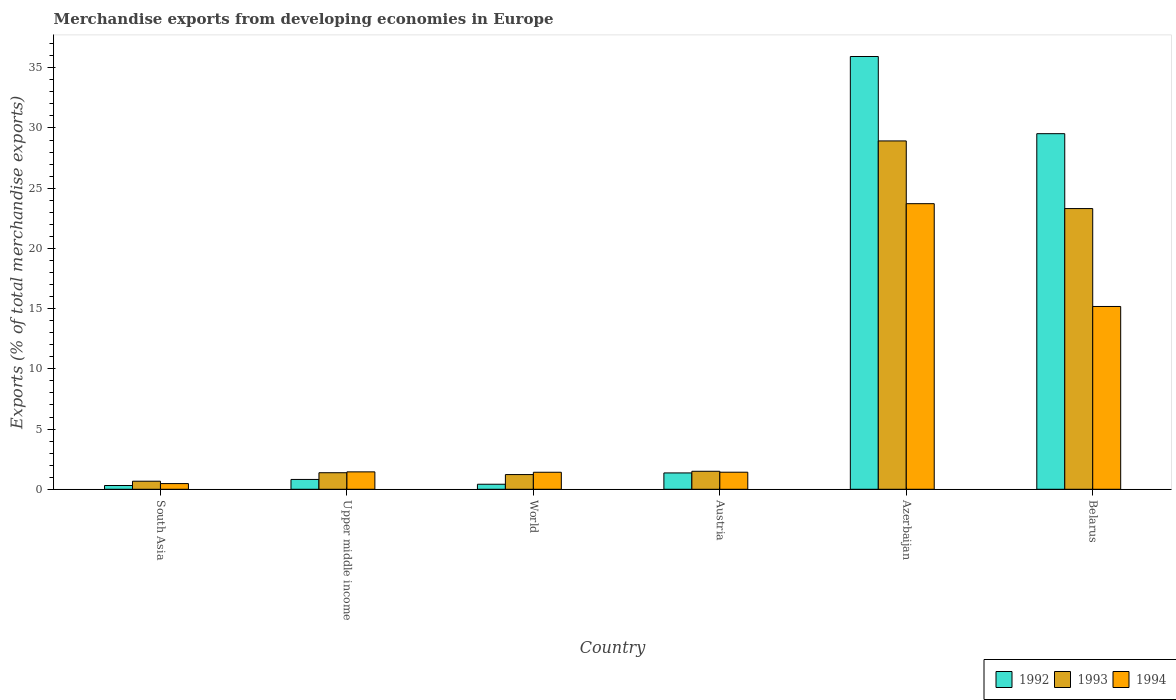How many groups of bars are there?
Ensure brevity in your answer.  6. Are the number of bars per tick equal to the number of legend labels?
Make the answer very short. Yes. How many bars are there on the 5th tick from the left?
Provide a succinct answer. 3. How many bars are there on the 2nd tick from the right?
Offer a very short reply. 3. What is the label of the 6th group of bars from the left?
Offer a terse response. Belarus. In how many cases, is the number of bars for a given country not equal to the number of legend labels?
Offer a terse response. 0. What is the percentage of total merchandise exports in 1992 in South Asia?
Provide a short and direct response. 0.31. Across all countries, what is the maximum percentage of total merchandise exports in 1994?
Provide a short and direct response. 23.72. Across all countries, what is the minimum percentage of total merchandise exports in 1994?
Provide a succinct answer. 0.47. In which country was the percentage of total merchandise exports in 1993 maximum?
Keep it short and to the point. Azerbaijan. What is the total percentage of total merchandise exports in 1992 in the graph?
Your response must be concise. 68.37. What is the difference between the percentage of total merchandise exports in 1992 in Belarus and that in World?
Make the answer very short. 29.11. What is the difference between the percentage of total merchandise exports in 1992 in Azerbaijan and the percentage of total merchandise exports in 1994 in South Asia?
Keep it short and to the point. 35.46. What is the average percentage of total merchandise exports in 1994 per country?
Give a very brief answer. 7.27. What is the difference between the percentage of total merchandise exports of/in 1994 and percentage of total merchandise exports of/in 1992 in Azerbaijan?
Offer a terse response. -12.22. In how many countries, is the percentage of total merchandise exports in 1994 greater than 14 %?
Offer a terse response. 2. What is the ratio of the percentage of total merchandise exports in 1994 in Austria to that in Azerbaijan?
Your answer should be very brief. 0.06. Is the percentage of total merchandise exports in 1993 in Austria less than that in World?
Ensure brevity in your answer.  No. What is the difference between the highest and the second highest percentage of total merchandise exports in 1994?
Your answer should be very brief. -13.73. What is the difference between the highest and the lowest percentage of total merchandise exports in 1993?
Offer a terse response. 28.26. In how many countries, is the percentage of total merchandise exports in 1992 greater than the average percentage of total merchandise exports in 1992 taken over all countries?
Your answer should be compact. 2. What does the 1st bar from the left in South Asia represents?
Ensure brevity in your answer.  1992. What does the 1st bar from the right in South Asia represents?
Provide a short and direct response. 1994. Is it the case that in every country, the sum of the percentage of total merchandise exports in 1992 and percentage of total merchandise exports in 1994 is greater than the percentage of total merchandise exports in 1993?
Provide a short and direct response. Yes. Are the values on the major ticks of Y-axis written in scientific E-notation?
Offer a terse response. No. Does the graph contain any zero values?
Offer a terse response. No. Does the graph contain grids?
Offer a very short reply. No. How many legend labels are there?
Make the answer very short. 3. What is the title of the graph?
Your response must be concise. Merchandise exports from developing economies in Europe. Does "1993" appear as one of the legend labels in the graph?
Your answer should be very brief. Yes. What is the label or title of the Y-axis?
Offer a very short reply. Exports (% of total merchandise exports). What is the Exports (% of total merchandise exports) in 1992 in South Asia?
Ensure brevity in your answer.  0.31. What is the Exports (% of total merchandise exports) in 1993 in South Asia?
Provide a short and direct response. 0.67. What is the Exports (% of total merchandise exports) in 1994 in South Asia?
Ensure brevity in your answer.  0.47. What is the Exports (% of total merchandise exports) in 1992 in Upper middle income?
Provide a succinct answer. 0.82. What is the Exports (% of total merchandise exports) in 1993 in Upper middle income?
Offer a very short reply. 1.37. What is the Exports (% of total merchandise exports) of 1994 in Upper middle income?
Make the answer very short. 1.45. What is the Exports (% of total merchandise exports) of 1992 in World?
Your answer should be very brief. 0.42. What is the Exports (% of total merchandise exports) of 1993 in World?
Give a very brief answer. 1.22. What is the Exports (% of total merchandise exports) of 1994 in World?
Make the answer very short. 1.41. What is the Exports (% of total merchandise exports) in 1992 in Austria?
Your answer should be very brief. 1.36. What is the Exports (% of total merchandise exports) of 1993 in Austria?
Give a very brief answer. 1.49. What is the Exports (% of total merchandise exports) of 1994 in Austria?
Your response must be concise. 1.42. What is the Exports (% of total merchandise exports) in 1992 in Azerbaijan?
Ensure brevity in your answer.  35.94. What is the Exports (% of total merchandise exports) in 1993 in Azerbaijan?
Ensure brevity in your answer.  28.93. What is the Exports (% of total merchandise exports) of 1994 in Azerbaijan?
Give a very brief answer. 23.72. What is the Exports (% of total merchandise exports) of 1992 in Belarus?
Make the answer very short. 29.53. What is the Exports (% of total merchandise exports) of 1993 in Belarus?
Give a very brief answer. 23.31. What is the Exports (% of total merchandise exports) in 1994 in Belarus?
Make the answer very short. 15.18. Across all countries, what is the maximum Exports (% of total merchandise exports) of 1992?
Provide a short and direct response. 35.94. Across all countries, what is the maximum Exports (% of total merchandise exports) of 1993?
Offer a very short reply. 28.93. Across all countries, what is the maximum Exports (% of total merchandise exports) of 1994?
Keep it short and to the point. 23.72. Across all countries, what is the minimum Exports (% of total merchandise exports) of 1992?
Provide a succinct answer. 0.31. Across all countries, what is the minimum Exports (% of total merchandise exports) in 1993?
Make the answer very short. 0.67. Across all countries, what is the minimum Exports (% of total merchandise exports) in 1994?
Give a very brief answer. 0.47. What is the total Exports (% of total merchandise exports) of 1992 in the graph?
Ensure brevity in your answer.  68.37. What is the total Exports (% of total merchandise exports) in 1993 in the graph?
Your answer should be very brief. 57. What is the total Exports (% of total merchandise exports) in 1994 in the graph?
Offer a very short reply. 43.64. What is the difference between the Exports (% of total merchandise exports) of 1992 in South Asia and that in Upper middle income?
Your response must be concise. -0.5. What is the difference between the Exports (% of total merchandise exports) in 1993 in South Asia and that in Upper middle income?
Your answer should be very brief. -0.7. What is the difference between the Exports (% of total merchandise exports) in 1994 in South Asia and that in Upper middle income?
Offer a very short reply. -0.97. What is the difference between the Exports (% of total merchandise exports) of 1992 in South Asia and that in World?
Ensure brevity in your answer.  -0.11. What is the difference between the Exports (% of total merchandise exports) in 1993 in South Asia and that in World?
Your response must be concise. -0.55. What is the difference between the Exports (% of total merchandise exports) in 1994 in South Asia and that in World?
Offer a terse response. -0.94. What is the difference between the Exports (% of total merchandise exports) of 1992 in South Asia and that in Austria?
Offer a terse response. -1.04. What is the difference between the Exports (% of total merchandise exports) of 1993 in South Asia and that in Austria?
Make the answer very short. -0.82. What is the difference between the Exports (% of total merchandise exports) of 1994 in South Asia and that in Austria?
Provide a succinct answer. -0.94. What is the difference between the Exports (% of total merchandise exports) of 1992 in South Asia and that in Azerbaijan?
Ensure brevity in your answer.  -35.62. What is the difference between the Exports (% of total merchandise exports) of 1993 in South Asia and that in Azerbaijan?
Make the answer very short. -28.26. What is the difference between the Exports (% of total merchandise exports) of 1994 in South Asia and that in Azerbaijan?
Provide a succinct answer. -23.24. What is the difference between the Exports (% of total merchandise exports) in 1992 in South Asia and that in Belarus?
Provide a short and direct response. -29.21. What is the difference between the Exports (% of total merchandise exports) in 1993 in South Asia and that in Belarus?
Your response must be concise. -22.64. What is the difference between the Exports (% of total merchandise exports) of 1994 in South Asia and that in Belarus?
Offer a terse response. -14.71. What is the difference between the Exports (% of total merchandise exports) of 1992 in Upper middle income and that in World?
Offer a terse response. 0.4. What is the difference between the Exports (% of total merchandise exports) of 1993 in Upper middle income and that in World?
Your answer should be very brief. 0.15. What is the difference between the Exports (% of total merchandise exports) in 1994 in Upper middle income and that in World?
Make the answer very short. 0.03. What is the difference between the Exports (% of total merchandise exports) of 1992 in Upper middle income and that in Austria?
Offer a terse response. -0.54. What is the difference between the Exports (% of total merchandise exports) of 1993 in Upper middle income and that in Austria?
Keep it short and to the point. -0.12. What is the difference between the Exports (% of total merchandise exports) in 1994 in Upper middle income and that in Austria?
Your answer should be compact. 0.03. What is the difference between the Exports (% of total merchandise exports) in 1992 in Upper middle income and that in Azerbaijan?
Ensure brevity in your answer.  -35.12. What is the difference between the Exports (% of total merchandise exports) in 1993 in Upper middle income and that in Azerbaijan?
Provide a succinct answer. -27.55. What is the difference between the Exports (% of total merchandise exports) in 1994 in Upper middle income and that in Azerbaijan?
Offer a terse response. -22.27. What is the difference between the Exports (% of total merchandise exports) in 1992 in Upper middle income and that in Belarus?
Your response must be concise. -28.71. What is the difference between the Exports (% of total merchandise exports) in 1993 in Upper middle income and that in Belarus?
Provide a succinct answer. -21.93. What is the difference between the Exports (% of total merchandise exports) in 1994 in Upper middle income and that in Belarus?
Offer a terse response. -13.73. What is the difference between the Exports (% of total merchandise exports) of 1992 in World and that in Austria?
Provide a short and direct response. -0.94. What is the difference between the Exports (% of total merchandise exports) in 1993 in World and that in Austria?
Offer a very short reply. -0.27. What is the difference between the Exports (% of total merchandise exports) in 1994 in World and that in Austria?
Make the answer very short. -0. What is the difference between the Exports (% of total merchandise exports) of 1992 in World and that in Azerbaijan?
Provide a succinct answer. -35.52. What is the difference between the Exports (% of total merchandise exports) of 1993 in World and that in Azerbaijan?
Offer a very short reply. -27.7. What is the difference between the Exports (% of total merchandise exports) of 1994 in World and that in Azerbaijan?
Give a very brief answer. -22.3. What is the difference between the Exports (% of total merchandise exports) of 1992 in World and that in Belarus?
Offer a terse response. -29.11. What is the difference between the Exports (% of total merchandise exports) of 1993 in World and that in Belarus?
Keep it short and to the point. -22.09. What is the difference between the Exports (% of total merchandise exports) in 1994 in World and that in Belarus?
Make the answer very short. -13.77. What is the difference between the Exports (% of total merchandise exports) of 1992 in Austria and that in Azerbaijan?
Provide a succinct answer. -34.58. What is the difference between the Exports (% of total merchandise exports) of 1993 in Austria and that in Azerbaijan?
Give a very brief answer. -27.43. What is the difference between the Exports (% of total merchandise exports) of 1994 in Austria and that in Azerbaijan?
Offer a terse response. -22.3. What is the difference between the Exports (% of total merchandise exports) in 1992 in Austria and that in Belarus?
Provide a short and direct response. -28.17. What is the difference between the Exports (% of total merchandise exports) of 1993 in Austria and that in Belarus?
Give a very brief answer. -21.81. What is the difference between the Exports (% of total merchandise exports) in 1994 in Austria and that in Belarus?
Ensure brevity in your answer.  -13.76. What is the difference between the Exports (% of total merchandise exports) of 1992 in Azerbaijan and that in Belarus?
Make the answer very short. 6.41. What is the difference between the Exports (% of total merchandise exports) in 1993 in Azerbaijan and that in Belarus?
Keep it short and to the point. 5.62. What is the difference between the Exports (% of total merchandise exports) of 1994 in Azerbaijan and that in Belarus?
Provide a succinct answer. 8.54. What is the difference between the Exports (% of total merchandise exports) of 1992 in South Asia and the Exports (% of total merchandise exports) of 1993 in Upper middle income?
Make the answer very short. -1.06. What is the difference between the Exports (% of total merchandise exports) in 1992 in South Asia and the Exports (% of total merchandise exports) in 1994 in Upper middle income?
Provide a short and direct response. -1.13. What is the difference between the Exports (% of total merchandise exports) of 1993 in South Asia and the Exports (% of total merchandise exports) of 1994 in Upper middle income?
Your response must be concise. -0.78. What is the difference between the Exports (% of total merchandise exports) of 1992 in South Asia and the Exports (% of total merchandise exports) of 1993 in World?
Ensure brevity in your answer.  -0.91. What is the difference between the Exports (% of total merchandise exports) in 1992 in South Asia and the Exports (% of total merchandise exports) in 1994 in World?
Give a very brief answer. -1.1. What is the difference between the Exports (% of total merchandise exports) of 1993 in South Asia and the Exports (% of total merchandise exports) of 1994 in World?
Your answer should be compact. -0.74. What is the difference between the Exports (% of total merchandise exports) of 1992 in South Asia and the Exports (% of total merchandise exports) of 1993 in Austria?
Give a very brief answer. -1.18. What is the difference between the Exports (% of total merchandise exports) of 1992 in South Asia and the Exports (% of total merchandise exports) of 1994 in Austria?
Your answer should be very brief. -1.1. What is the difference between the Exports (% of total merchandise exports) of 1993 in South Asia and the Exports (% of total merchandise exports) of 1994 in Austria?
Provide a short and direct response. -0.75. What is the difference between the Exports (% of total merchandise exports) in 1992 in South Asia and the Exports (% of total merchandise exports) in 1993 in Azerbaijan?
Give a very brief answer. -28.61. What is the difference between the Exports (% of total merchandise exports) of 1992 in South Asia and the Exports (% of total merchandise exports) of 1994 in Azerbaijan?
Your answer should be compact. -23.4. What is the difference between the Exports (% of total merchandise exports) of 1993 in South Asia and the Exports (% of total merchandise exports) of 1994 in Azerbaijan?
Your answer should be compact. -23.05. What is the difference between the Exports (% of total merchandise exports) of 1992 in South Asia and the Exports (% of total merchandise exports) of 1993 in Belarus?
Provide a succinct answer. -23. What is the difference between the Exports (% of total merchandise exports) of 1992 in South Asia and the Exports (% of total merchandise exports) of 1994 in Belarus?
Ensure brevity in your answer.  -14.87. What is the difference between the Exports (% of total merchandise exports) of 1993 in South Asia and the Exports (% of total merchandise exports) of 1994 in Belarus?
Give a very brief answer. -14.51. What is the difference between the Exports (% of total merchandise exports) of 1992 in Upper middle income and the Exports (% of total merchandise exports) of 1993 in World?
Make the answer very short. -0.41. What is the difference between the Exports (% of total merchandise exports) in 1992 in Upper middle income and the Exports (% of total merchandise exports) in 1994 in World?
Ensure brevity in your answer.  -0.6. What is the difference between the Exports (% of total merchandise exports) of 1993 in Upper middle income and the Exports (% of total merchandise exports) of 1994 in World?
Offer a terse response. -0.04. What is the difference between the Exports (% of total merchandise exports) of 1992 in Upper middle income and the Exports (% of total merchandise exports) of 1993 in Austria?
Your response must be concise. -0.68. What is the difference between the Exports (% of total merchandise exports) in 1992 in Upper middle income and the Exports (% of total merchandise exports) in 1994 in Austria?
Provide a succinct answer. -0.6. What is the difference between the Exports (% of total merchandise exports) in 1993 in Upper middle income and the Exports (% of total merchandise exports) in 1994 in Austria?
Make the answer very short. -0.04. What is the difference between the Exports (% of total merchandise exports) in 1992 in Upper middle income and the Exports (% of total merchandise exports) in 1993 in Azerbaijan?
Your response must be concise. -28.11. What is the difference between the Exports (% of total merchandise exports) in 1992 in Upper middle income and the Exports (% of total merchandise exports) in 1994 in Azerbaijan?
Offer a terse response. -22.9. What is the difference between the Exports (% of total merchandise exports) in 1993 in Upper middle income and the Exports (% of total merchandise exports) in 1994 in Azerbaijan?
Your response must be concise. -22.34. What is the difference between the Exports (% of total merchandise exports) of 1992 in Upper middle income and the Exports (% of total merchandise exports) of 1993 in Belarus?
Your answer should be very brief. -22.49. What is the difference between the Exports (% of total merchandise exports) in 1992 in Upper middle income and the Exports (% of total merchandise exports) in 1994 in Belarus?
Keep it short and to the point. -14.36. What is the difference between the Exports (% of total merchandise exports) in 1993 in Upper middle income and the Exports (% of total merchandise exports) in 1994 in Belarus?
Offer a terse response. -13.8. What is the difference between the Exports (% of total merchandise exports) of 1992 in World and the Exports (% of total merchandise exports) of 1993 in Austria?
Offer a very short reply. -1.08. What is the difference between the Exports (% of total merchandise exports) in 1992 in World and the Exports (% of total merchandise exports) in 1994 in Austria?
Your response must be concise. -1. What is the difference between the Exports (% of total merchandise exports) in 1993 in World and the Exports (% of total merchandise exports) in 1994 in Austria?
Your answer should be compact. -0.2. What is the difference between the Exports (% of total merchandise exports) in 1992 in World and the Exports (% of total merchandise exports) in 1993 in Azerbaijan?
Give a very brief answer. -28.51. What is the difference between the Exports (% of total merchandise exports) in 1992 in World and the Exports (% of total merchandise exports) in 1994 in Azerbaijan?
Give a very brief answer. -23.3. What is the difference between the Exports (% of total merchandise exports) of 1993 in World and the Exports (% of total merchandise exports) of 1994 in Azerbaijan?
Give a very brief answer. -22.49. What is the difference between the Exports (% of total merchandise exports) of 1992 in World and the Exports (% of total merchandise exports) of 1993 in Belarus?
Keep it short and to the point. -22.89. What is the difference between the Exports (% of total merchandise exports) of 1992 in World and the Exports (% of total merchandise exports) of 1994 in Belarus?
Give a very brief answer. -14.76. What is the difference between the Exports (% of total merchandise exports) of 1993 in World and the Exports (% of total merchandise exports) of 1994 in Belarus?
Your response must be concise. -13.96. What is the difference between the Exports (% of total merchandise exports) in 1992 in Austria and the Exports (% of total merchandise exports) in 1993 in Azerbaijan?
Make the answer very short. -27.57. What is the difference between the Exports (% of total merchandise exports) of 1992 in Austria and the Exports (% of total merchandise exports) of 1994 in Azerbaijan?
Your answer should be compact. -22.36. What is the difference between the Exports (% of total merchandise exports) in 1993 in Austria and the Exports (% of total merchandise exports) in 1994 in Azerbaijan?
Provide a succinct answer. -22.22. What is the difference between the Exports (% of total merchandise exports) of 1992 in Austria and the Exports (% of total merchandise exports) of 1993 in Belarus?
Offer a very short reply. -21.95. What is the difference between the Exports (% of total merchandise exports) in 1992 in Austria and the Exports (% of total merchandise exports) in 1994 in Belarus?
Your answer should be compact. -13.82. What is the difference between the Exports (% of total merchandise exports) in 1993 in Austria and the Exports (% of total merchandise exports) in 1994 in Belarus?
Ensure brevity in your answer.  -13.68. What is the difference between the Exports (% of total merchandise exports) of 1992 in Azerbaijan and the Exports (% of total merchandise exports) of 1993 in Belarus?
Ensure brevity in your answer.  12.63. What is the difference between the Exports (% of total merchandise exports) in 1992 in Azerbaijan and the Exports (% of total merchandise exports) in 1994 in Belarus?
Give a very brief answer. 20.76. What is the difference between the Exports (% of total merchandise exports) in 1993 in Azerbaijan and the Exports (% of total merchandise exports) in 1994 in Belarus?
Offer a terse response. 13.75. What is the average Exports (% of total merchandise exports) in 1992 per country?
Give a very brief answer. 11.39. What is the average Exports (% of total merchandise exports) of 1993 per country?
Your answer should be very brief. 9.5. What is the average Exports (% of total merchandise exports) in 1994 per country?
Provide a short and direct response. 7.27. What is the difference between the Exports (% of total merchandise exports) of 1992 and Exports (% of total merchandise exports) of 1993 in South Asia?
Make the answer very short. -0.36. What is the difference between the Exports (% of total merchandise exports) of 1992 and Exports (% of total merchandise exports) of 1994 in South Asia?
Offer a very short reply. -0.16. What is the difference between the Exports (% of total merchandise exports) of 1993 and Exports (% of total merchandise exports) of 1994 in South Asia?
Make the answer very short. 0.2. What is the difference between the Exports (% of total merchandise exports) in 1992 and Exports (% of total merchandise exports) in 1993 in Upper middle income?
Offer a very short reply. -0.56. What is the difference between the Exports (% of total merchandise exports) in 1992 and Exports (% of total merchandise exports) in 1994 in Upper middle income?
Your answer should be compact. -0.63. What is the difference between the Exports (% of total merchandise exports) of 1993 and Exports (% of total merchandise exports) of 1994 in Upper middle income?
Provide a short and direct response. -0.07. What is the difference between the Exports (% of total merchandise exports) in 1992 and Exports (% of total merchandise exports) in 1993 in World?
Provide a short and direct response. -0.8. What is the difference between the Exports (% of total merchandise exports) in 1992 and Exports (% of total merchandise exports) in 1994 in World?
Ensure brevity in your answer.  -0.99. What is the difference between the Exports (% of total merchandise exports) in 1993 and Exports (% of total merchandise exports) in 1994 in World?
Provide a short and direct response. -0.19. What is the difference between the Exports (% of total merchandise exports) of 1992 and Exports (% of total merchandise exports) of 1993 in Austria?
Provide a succinct answer. -0.14. What is the difference between the Exports (% of total merchandise exports) in 1992 and Exports (% of total merchandise exports) in 1994 in Austria?
Your response must be concise. -0.06. What is the difference between the Exports (% of total merchandise exports) of 1993 and Exports (% of total merchandise exports) of 1994 in Austria?
Your answer should be very brief. 0.08. What is the difference between the Exports (% of total merchandise exports) of 1992 and Exports (% of total merchandise exports) of 1993 in Azerbaijan?
Offer a terse response. 7.01. What is the difference between the Exports (% of total merchandise exports) in 1992 and Exports (% of total merchandise exports) in 1994 in Azerbaijan?
Keep it short and to the point. 12.22. What is the difference between the Exports (% of total merchandise exports) in 1993 and Exports (% of total merchandise exports) in 1994 in Azerbaijan?
Make the answer very short. 5.21. What is the difference between the Exports (% of total merchandise exports) in 1992 and Exports (% of total merchandise exports) in 1993 in Belarus?
Offer a terse response. 6.22. What is the difference between the Exports (% of total merchandise exports) in 1992 and Exports (% of total merchandise exports) in 1994 in Belarus?
Keep it short and to the point. 14.35. What is the difference between the Exports (% of total merchandise exports) in 1993 and Exports (% of total merchandise exports) in 1994 in Belarus?
Offer a terse response. 8.13. What is the ratio of the Exports (% of total merchandise exports) in 1992 in South Asia to that in Upper middle income?
Your answer should be compact. 0.38. What is the ratio of the Exports (% of total merchandise exports) of 1993 in South Asia to that in Upper middle income?
Your answer should be very brief. 0.49. What is the ratio of the Exports (% of total merchandise exports) in 1994 in South Asia to that in Upper middle income?
Your answer should be very brief. 0.33. What is the ratio of the Exports (% of total merchandise exports) of 1992 in South Asia to that in World?
Offer a terse response. 0.75. What is the ratio of the Exports (% of total merchandise exports) in 1993 in South Asia to that in World?
Keep it short and to the point. 0.55. What is the ratio of the Exports (% of total merchandise exports) in 1994 in South Asia to that in World?
Give a very brief answer. 0.33. What is the ratio of the Exports (% of total merchandise exports) in 1992 in South Asia to that in Austria?
Offer a terse response. 0.23. What is the ratio of the Exports (% of total merchandise exports) in 1993 in South Asia to that in Austria?
Keep it short and to the point. 0.45. What is the ratio of the Exports (% of total merchandise exports) of 1994 in South Asia to that in Austria?
Give a very brief answer. 0.33. What is the ratio of the Exports (% of total merchandise exports) in 1992 in South Asia to that in Azerbaijan?
Ensure brevity in your answer.  0.01. What is the ratio of the Exports (% of total merchandise exports) of 1993 in South Asia to that in Azerbaijan?
Make the answer very short. 0.02. What is the ratio of the Exports (% of total merchandise exports) in 1994 in South Asia to that in Azerbaijan?
Your response must be concise. 0.02. What is the ratio of the Exports (% of total merchandise exports) in 1992 in South Asia to that in Belarus?
Provide a short and direct response. 0.01. What is the ratio of the Exports (% of total merchandise exports) in 1993 in South Asia to that in Belarus?
Provide a succinct answer. 0.03. What is the ratio of the Exports (% of total merchandise exports) in 1994 in South Asia to that in Belarus?
Ensure brevity in your answer.  0.03. What is the ratio of the Exports (% of total merchandise exports) in 1992 in Upper middle income to that in World?
Provide a succinct answer. 1.95. What is the ratio of the Exports (% of total merchandise exports) in 1993 in Upper middle income to that in World?
Offer a terse response. 1.13. What is the ratio of the Exports (% of total merchandise exports) in 1994 in Upper middle income to that in World?
Give a very brief answer. 1.02. What is the ratio of the Exports (% of total merchandise exports) of 1992 in Upper middle income to that in Austria?
Your response must be concise. 0.6. What is the ratio of the Exports (% of total merchandise exports) of 1993 in Upper middle income to that in Austria?
Your response must be concise. 0.92. What is the ratio of the Exports (% of total merchandise exports) of 1994 in Upper middle income to that in Austria?
Your answer should be very brief. 1.02. What is the ratio of the Exports (% of total merchandise exports) of 1992 in Upper middle income to that in Azerbaijan?
Give a very brief answer. 0.02. What is the ratio of the Exports (% of total merchandise exports) in 1993 in Upper middle income to that in Azerbaijan?
Make the answer very short. 0.05. What is the ratio of the Exports (% of total merchandise exports) in 1994 in Upper middle income to that in Azerbaijan?
Give a very brief answer. 0.06. What is the ratio of the Exports (% of total merchandise exports) of 1992 in Upper middle income to that in Belarus?
Provide a succinct answer. 0.03. What is the ratio of the Exports (% of total merchandise exports) in 1993 in Upper middle income to that in Belarus?
Offer a very short reply. 0.06. What is the ratio of the Exports (% of total merchandise exports) in 1994 in Upper middle income to that in Belarus?
Your response must be concise. 0.1. What is the ratio of the Exports (% of total merchandise exports) of 1992 in World to that in Austria?
Make the answer very short. 0.31. What is the ratio of the Exports (% of total merchandise exports) of 1993 in World to that in Austria?
Provide a short and direct response. 0.82. What is the ratio of the Exports (% of total merchandise exports) in 1994 in World to that in Austria?
Make the answer very short. 1. What is the ratio of the Exports (% of total merchandise exports) in 1992 in World to that in Azerbaijan?
Your answer should be compact. 0.01. What is the ratio of the Exports (% of total merchandise exports) of 1993 in World to that in Azerbaijan?
Your response must be concise. 0.04. What is the ratio of the Exports (% of total merchandise exports) of 1994 in World to that in Azerbaijan?
Your response must be concise. 0.06. What is the ratio of the Exports (% of total merchandise exports) in 1992 in World to that in Belarus?
Ensure brevity in your answer.  0.01. What is the ratio of the Exports (% of total merchandise exports) of 1993 in World to that in Belarus?
Provide a short and direct response. 0.05. What is the ratio of the Exports (% of total merchandise exports) of 1994 in World to that in Belarus?
Your response must be concise. 0.09. What is the ratio of the Exports (% of total merchandise exports) in 1992 in Austria to that in Azerbaijan?
Provide a succinct answer. 0.04. What is the ratio of the Exports (% of total merchandise exports) of 1993 in Austria to that in Azerbaijan?
Offer a terse response. 0.05. What is the ratio of the Exports (% of total merchandise exports) in 1994 in Austria to that in Azerbaijan?
Give a very brief answer. 0.06. What is the ratio of the Exports (% of total merchandise exports) in 1992 in Austria to that in Belarus?
Offer a very short reply. 0.05. What is the ratio of the Exports (% of total merchandise exports) of 1993 in Austria to that in Belarus?
Make the answer very short. 0.06. What is the ratio of the Exports (% of total merchandise exports) of 1994 in Austria to that in Belarus?
Ensure brevity in your answer.  0.09. What is the ratio of the Exports (% of total merchandise exports) of 1992 in Azerbaijan to that in Belarus?
Your answer should be compact. 1.22. What is the ratio of the Exports (% of total merchandise exports) in 1993 in Azerbaijan to that in Belarus?
Keep it short and to the point. 1.24. What is the ratio of the Exports (% of total merchandise exports) of 1994 in Azerbaijan to that in Belarus?
Your response must be concise. 1.56. What is the difference between the highest and the second highest Exports (% of total merchandise exports) of 1992?
Keep it short and to the point. 6.41. What is the difference between the highest and the second highest Exports (% of total merchandise exports) in 1993?
Your response must be concise. 5.62. What is the difference between the highest and the second highest Exports (% of total merchandise exports) of 1994?
Make the answer very short. 8.54. What is the difference between the highest and the lowest Exports (% of total merchandise exports) in 1992?
Make the answer very short. 35.62. What is the difference between the highest and the lowest Exports (% of total merchandise exports) in 1993?
Offer a terse response. 28.26. What is the difference between the highest and the lowest Exports (% of total merchandise exports) of 1994?
Keep it short and to the point. 23.24. 